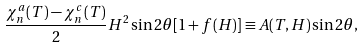<formula> <loc_0><loc_0><loc_500><loc_500>\frac { \chi ^ { a } _ { n } ( T ) - \chi ^ { c } _ { n } ( T ) } { 2 } H ^ { 2 } \sin 2 \theta [ 1 + f ( H ) ] \equiv A ( T , H ) \sin 2 \theta ,</formula> 